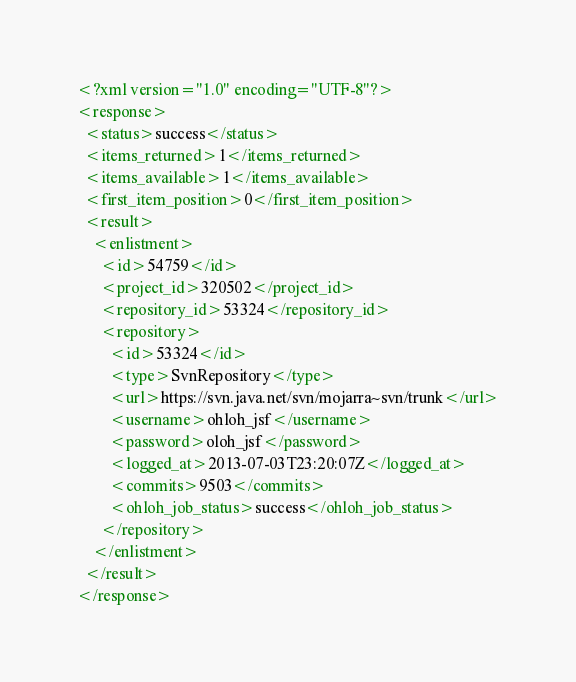<code> <loc_0><loc_0><loc_500><loc_500><_XML_><?xml version="1.0" encoding="UTF-8"?>
<response>
  <status>success</status>
  <items_returned>1</items_returned>
  <items_available>1</items_available>
  <first_item_position>0</first_item_position>
  <result>
    <enlistment>
      <id>54759</id>
      <project_id>320502</project_id>
      <repository_id>53324</repository_id>
      <repository>
        <id>53324</id>
        <type>SvnRepository</type>
        <url>https://svn.java.net/svn/mojarra~svn/trunk</url>
        <username>ohloh_jsf</username>
        <password>oloh_jsf</password>
        <logged_at>2013-07-03T23:20:07Z</logged_at>
        <commits>9503</commits>
        <ohloh_job_status>success</ohloh_job_status>
      </repository>
    </enlistment>
  </result>
</response>
</code> 